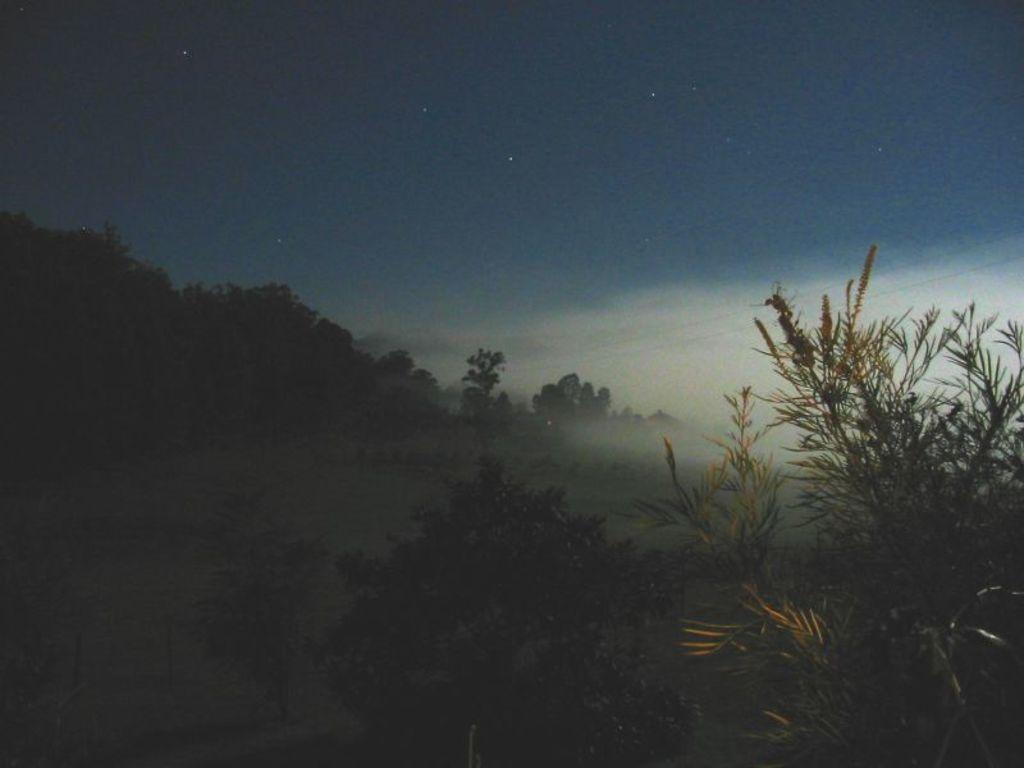What time of day was the image taken? The image was taken during night time. What type of vegetation can be seen in the image? There are trees in the image. What is visible in the sky in the image? The sky is visible in the image, and it contains clouds and stars. What type of eggs are being used to make the shirt in the image? There are no eggs or shirts present in the image; it features a nighttime scene with trees and a starry sky. 